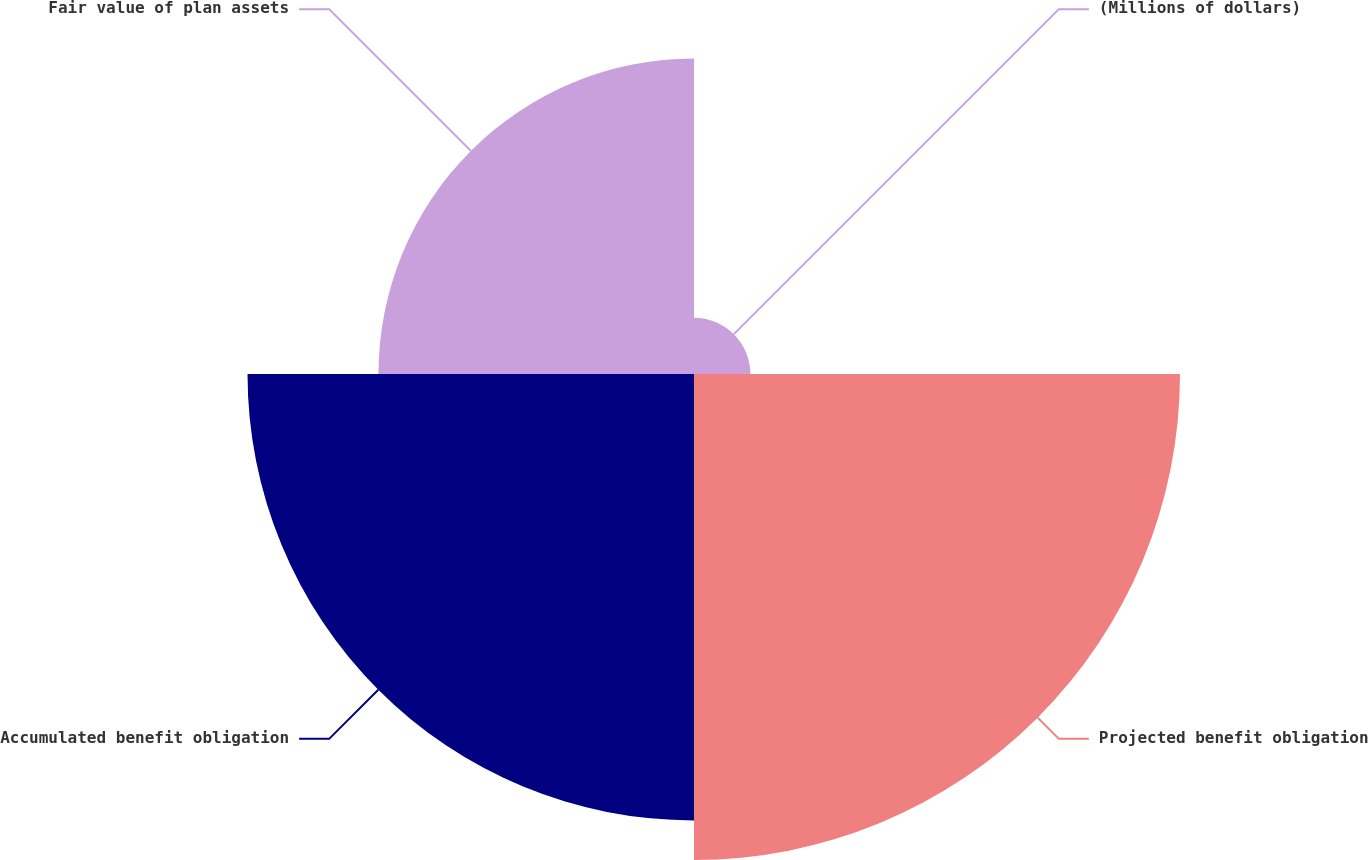Convert chart. <chart><loc_0><loc_0><loc_500><loc_500><pie_chart><fcel>(Millions of dollars)<fcel>Projected benefit obligation<fcel>Accumulated benefit obligation<fcel>Fair value of plan assets<nl><fcel>4.32%<fcel>37.26%<fcel>34.23%<fcel>24.19%<nl></chart> 